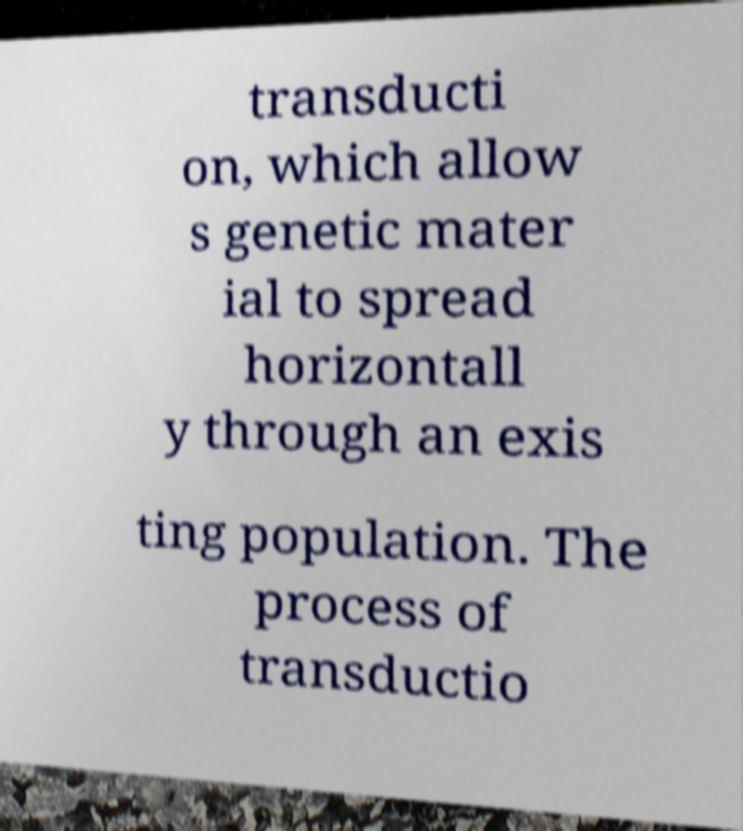Could you extract and type out the text from this image? transducti on, which allow s genetic mater ial to spread horizontall y through an exis ting population. The process of transductio 